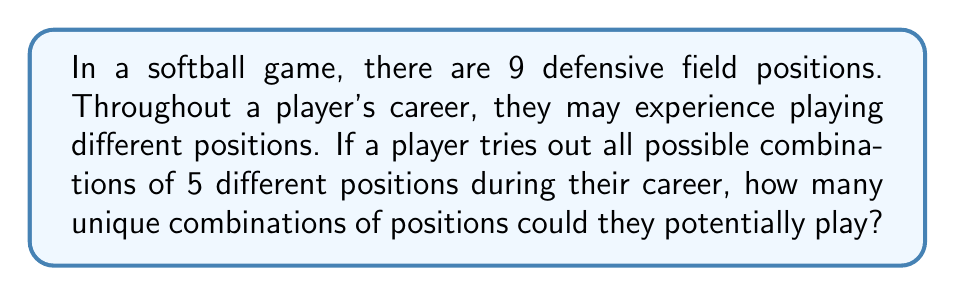Provide a solution to this math problem. Let's approach this step-by-step:

1) This is a combination problem. We're selecting 5 positions out of 9 total positions, where the order doesn't matter (it's about which positions are played, not the order they're played in).

2) The formula for combinations is:

   $$C(n,r) = \frac{n!}{r!(n-r)!}$$

   Where $n$ is the total number of items to choose from, and $r$ is the number of items being chosen.

3) In this case, $n = 9$ (total field positions) and $r = 5$ (positions played in career).

4) Plugging these values into our formula:

   $$C(9,5) = \frac{9!}{5!(9-5)!} = \frac{9!}{5!4!}$$

5) Expand this:
   
   $$\frac{9 * 8 * 7 * 6 * 5 * 4!}{(5 * 4 * 3 * 2 * 1) * 4!}$$

6) The $4!$ cancels out in the numerator and denominator:

   $$\frac{9 * 8 * 7 * 6 * 5}{5 * 4 * 3 * 2 * 1}$$

7) Multiply the numerator and denominator:

   $$\frac{15120}{120} = 126$$

Therefore, there are 126 unique combinations of 5 positions that a player could experience in their career.
Answer: 126 